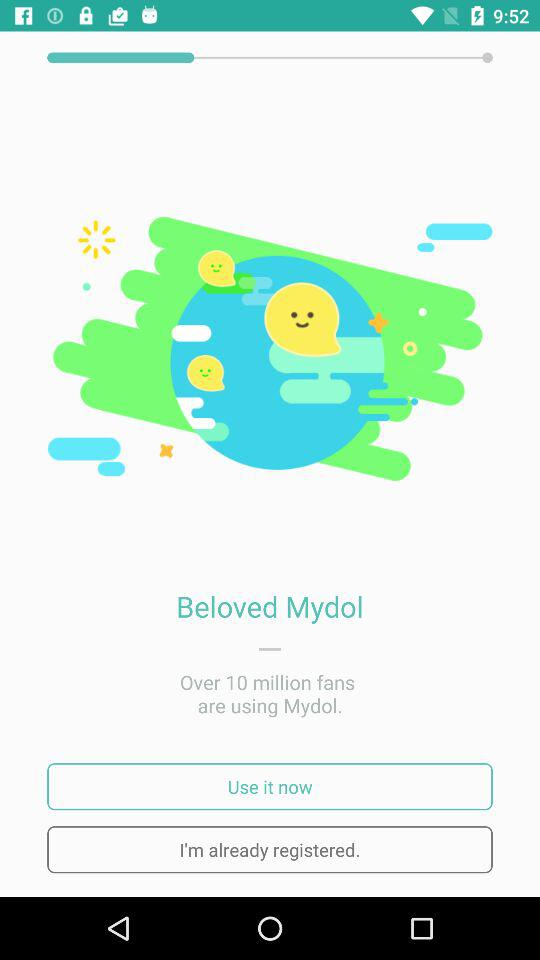How do you use "Mydol"?
When the provided information is insufficient, respond with <no answer>. <no answer> 